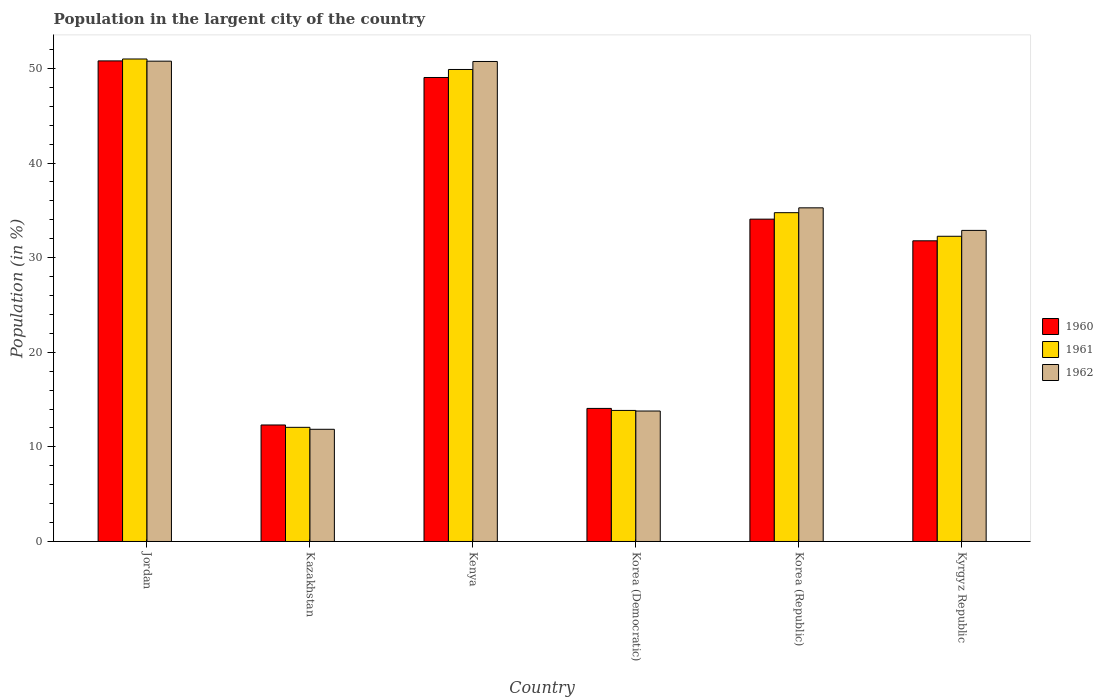How many different coloured bars are there?
Provide a succinct answer. 3. How many groups of bars are there?
Offer a very short reply. 6. Are the number of bars per tick equal to the number of legend labels?
Offer a terse response. Yes. How many bars are there on the 2nd tick from the right?
Offer a terse response. 3. What is the label of the 4th group of bars from the left?
Ensure brevity in your answer.  Korea (Democratic). In how many cases, is the number of bars for a given country not equal to the number of legend labels?
Provide a succinct answer. 0. What is the percentage of population in the largent city in 1961 in Kyrgyz Republic?
Your answer should be very brief. 32.26. Across all countries, what is the maximum percentage of population in the largent city in 1961?
Provide a succinct answer. 50.99. Across all countries, what is the minimum percentage of population in the largent city in 1962?
Keep it short and to the point. 11.86. In which country was the percentage of population in the largent city in 1962 maximum?
Ensure brevity in your answer.  Jordan. In which country was the percentage of population in the largent city in 1961 minimum?
Your answer should be very brief. Kazakhstan. What is the total percentage of population in the largent city in 1962 in the graph?
Your answer should be compact. 195.28. What is the difference between the percentage of population in the largent city in 1960 in Kazakhstan and that in Kenya?
Provide a short and direct response. -36.73. What is the difference between the percentage of population in the largent city in 1960 in Korea (Democratic) and the percentage of population in the largent city in 1961 in Kazakhstan?
Offer a terse response. 2. What is the average percentage of population in the largent city in 1962 per country?
Ensure brevity in your answer.  32.55. What is the difference between the percentage of population in the largent city of/in 1960 and percentage of population in the largent city of/in 1962 in Jordan?
Your answer should be compact. 0.03. In how many countries, is the percentage of population in the largent city in 1962 greater than 16 %?
Offer a terse response. 4. What is the ratio of the percentage of population in the largent city in 1960 in Jordan to that in Kyrgyz Republic?
Make the answer very short. 1.6. Is the percentage of population in the largent city in 1960 in Jordan less than that in Korea (Democratic)?
Provide a short and direct response. No. Is the difference between the percentage of population in the largent city in 1960 in Kenya and Korea (Republic) greater than the difference between the percentage of population in the largent city in 1962 in Kenya and Korea (Republic)?
Your response must be concise. No. What is the difference between the highest and the second highest percentage of population in the largent city in 1962?
Keep it short and to the point. 15.5. What is the difference between the highest and the lowest percentage of population in the largent city in 1961?
Provide a short and direct response. 38.93. Is the sum of the percentage of population in the largent city in 1960 in Korea (Democratic) and Kyrgyz Republic greater than the maximum percentage of population in the largent city in 1962 across all countries?
Your answer should be very brief. No. What does the 2nd bar from the left in Kenya represents?
Offer a very short reply. 1961. Is it the case that in every country, the sum of the percentage of population in the largent city in 1962 and percentage of population in the largent city in 1961 is greater than the percentage of population in the largent city in 1960?
Your answer should be compact. Yes. Does the graph contain grids?
Your answer should be compact. No. Where does the legend appear in the graph?
Offer a terse response. Center right. How many legend labels are there?
Make the answer very short. 3. How are the legend labels stacked?
Keep it short and to the point. Vertical. What is the title of the graph?
Your answer should be very brief. Population in the largent city of the country. What is the Population (in %) of 1960 in Jordan?
Your answer should be very brief. 50.79. What is the Population (in %) in 1961 in Jordan?
Offer a very short reply. 50.99. What is the Population (in %) of 1962 in Jordan?
Give a very brief answer. 50.76. What is the Population (in %) in 1960 in Kazakhstan?
Make the answer very short. 12.31. What is the Population (in %) in 1961 in Kazakhstan?
Provide a succinct answer. 12.06. What is the Population (in %) of 1962 in Kazakhstan?
Your answer should be compact. 11.86. What is the Population (in %) in 1960 in Kenya?
Your answer should be compact. 49.04. What is the Population (in %) in 1961 in Kenya?
Provide a short and direct response. 49.89. What is the Population (in %) of 1962 in Kenya?
Your answer should be very brief. 50.73. What is the Population (in %) in 1960 in Korea (Democratic)?
Give a very brief answer. 14.06. What is the Population (in %) of 1961 in Korea (Democratic)?
Offer a very short reply. 13.85. What is the Population (in %) in 1962 in Korea (Democratic)?
Offer a very short reply. 13.79. What is the Population (in %) of 1960 in Korea (Republic)?
Provide a short and direct response. 34.07. What is the Population (in %) of 1961 in Korea (Republic)?
Ensure brevity in your answer.  34.75. What is the Population (in %) of 1962 in Korea (Republic)?
Give a very brief answer. 35.26. What is the Population (in %) of 1960 in Kyrgyz Republic?
Give a very brief answer. 31.78. What is the Population (in %) of 1961 in Kyrgyz Republic?
Your answer should be compact. 32.26. What is the Population (in %) in 1962 in Kyrgyz Republic?
Your answer should be compact. 32.88. Across all countries, what is the maximum Population (in %) of 1960?
Offer a terse response. 50.79. Across all countries, what is the maximum Population (in %) of 1961?
Ensure brevity in your answer.  50.99. Across all countries, what is the maximum Population (in %) of 1962?
Give a very brief answer. 50.76. Across all countries, what is the minimum Population (in %) of 1960?
Provide a succinct answer. 12.31. Across all countries, what is the minimum Population (in %) in 1961?
Your response must be concise. 12.06. Across all countries, what is the minimum Population (in %) of 1962?
Your answer should be compact. 11.86. What is the total Population (in %) in 1960 in the graph?
Make the answer very short. 192.05. What is the total Population (in %) of 1961 in the graph?
Make the answer very short. 193.8. What is the total Population (in %) of 1962 in the graph?
Make the answer very short. 195.28. What is the difference between the Population (in %) of 1960 in Jordan and that in Kazakhstan?
Provide a succinct answer. 38.48. What is the difference between the Population (in %) of 1961 in Jordan and that in Kazakhstan?
Provide a succinct answer. 38.93. What is the difference between the Population (in %) in 1962 in Jordan and that in Kazakhstan?
Provide a short and direct response. 38.91. What is the difference between the Population (in %) in 1960 in Jordan and that in Kenya?
Offer a terse response. 1.75. What is the difference between the Population (in %) of 1961 in Jordan and that in Kenya?
Your answer should be compact. 1.11. What is the difference between the Population (in %) in 1962 in Jordan and that in Kenya?
Provide a succinct answer. 0.03. What is the difference between the Population (in %) of 1960 in Jordan and that in Korea (Democratic)?
Offer a very short reply. 36.73. What is the difference between the Population (in %) of 1961 in Jordan and that in Korea (Democratic)?
Provide a short and direct response. 37.14. What is the difference between the Population (in %) of 1962 in Jordan and that in Korea (Democratic)?
Give a very brief answer. 36.98. What is the difference between the Population (in %) of 1960 in Jordan and that in Korea (Republic)?
Keep it short and to the point. 16.73. What is the difference between the Population (in %) of 1961 in Jordan and that in Korea (Republic)?
Your answer should be very brief. 16.24. What is the difference between the Population (in %) of 1962 in Jordan and that in Korea (Republic)?
Keep it short and to the point. 15.5. What is the difference between the Population (in %) in 1960 in Jordan and that in Kyrgyz Republic?
Offer a very short reply. 19.01. What is the difference between the Population (in %) of 1961 in Jordan and that in Kyrgyz Republic?
Your answer should be very brief. 18.74. What is the difference between the Population (in %) in 1962 in Jordan and that in Kyrgyz Republic?
Ensure brevity in your answer.  17.89. What is the difference between the Population (in %) of 1960 in Kazakhstan and that in Kenya?
Offer a terse response. -36.73. What is the difference between the Population (in %) of 1961 in Kazakhstan and that in Kenya?
Give a very brief answer. -37.82. What is the difference between the Population (in %) of 1962 in Kazakhstan and that in Kenya?
Keep it short and to the point. -38.88. What is the difference between the Population (in %) in 1960 in Kazakhstan and that in Korea (Democratic)?
Provide a succinct answer. -1.75. What is the difference between the Population (in %) in 1961 in Kazakhstan and that in Korea (Democratic)?
Offer a terse response. -1.79. What is the difference between the Population (in %) in 1962 in Kazakhstan and that in Korea (Democratic)?
Provide a succinct answer. -1.93. What is the difference between the Population (in %) in 1960 in Kazakhstan and that in Korea (Republic)?
Offer a very short reply. -21.75. What is the difference between the Population (in %) of 1961 in Kazakhstan and that in Korea (Republic)?
Make the answer very short. -22.69. What is the difference between the Population (in %) of 1962 in Kazakhstan and that in Korea (Republic)?
Your response must be concise. -23.41. What is the difference between the Population (in %) of 1960 in Kazakhstan and that in Kyrgyz Republic?
Provide a short and direct response. -19.46. What is the difference between the Population (in %) in 1961 in Kazakhstan and that in Kyrgyz Republic?
Your answer should be compact. -20.19. What is the difference between the Population (in %) of 1962 in Kazakhstan and that in Kyrgyz Republic?
Offer a terse response. -21.02. What is the difference between the Population (in %) in 1960 in Kenya and that in Korea (Democratic)?
Your response must be concise. 34.97. What is the difference between the Population (in %) in 1961 in Kenya and that in Korea (Democratic)?
Ensure brevity in your answer.  36.04. What is the difference between the Population (in %) of 1962 in Kenya and that in Korea (Democratic)?
Offer a terse response. 36.94. What is the difference between the Population (in %) of 1960 in Kenya and that in Korea (Republic)?
Your answer should be compact. 14.97. What is the difference between the Population (in %) in 1961 in Kenya and that in Korea (Republic)?
Keep it short and to the point. 15.14. What is the difference between the Population (in %) in 1962 in Kenya and that in Korea (Republic)?
Make the answer very short. 15.47. What is the difference between the Population (in %) in 1960 in Kenya and that in Kyrgyz Republic?
Offer a very short reply. 17.26. What is the difference between the Population (in %) in 1961 in Kenya and that in Kyrgyz Republic?
Your answer should be very brief. 17.63. What is the difference between the Population (in %) of 1962 in Kenya and that in Kyrgyz Republic?
Provide a succinct answer. 17.85. What is the difference between the Population (in %) of 1960 in Korea (Democratic) and that in Korea (Republic)?
Offer a terse response. -20. What is the difference between the Population (in %) in 1961 in Korea (Democratic) and that in Korea (Republic)?
Provide a succinct answer. -20.9. What is the difference between the Population (in %) of 1962 in Korea (Democratic) and that in Korea (Republic)?
Offer a very short reply. -21.47. What is the difference between the Population (in %) in 1960 in Korea (Democratic) and that in Kyrgyz Republic?
Your answer should be very brief. -17.71. What is the difference between the Population (in %) of 1961 in Korea (Democratic) and that in Kyrgyz Republic?
Offer a very short reply. -18.41. What is the difference between the Population (in %) of 1962 in Korea (Democratic) and that in Kyrgyz Republic?
Make the answer very short. -19.09. What is the difference between the Population (in %) in 1960 in Korea (Republic) and that in Kyrgyz Republic?
Make the answer very short. 2.29. What is the difference between the Population (in %) in 1961 in Korea (Republic) and that in Kyrgyz Republic?
Make the answer very short. 2.49. What is the difference between the Population (in %) of 1962 in Korea (Republic) and that in Kyrgyz Republic?
Make the answer very short. 2.38. What is the difference between the Population (in %) of 1960 in Jordan and the Population (in %) of 1961 in Kazakhstan?
Keep it short and to the point. 38.73. What is the difference between the Population (in %) in 1960 in Jordan and the Population (in %) in 1962 in Kazakhstan?
Offer a terse response. 38.94. What is the difference between the Population (in %) of 1961 in Jordan and the Population (in %) of 1962 in Kazakhstan?
Your answer should be very brief. 39.14. What is the difference between the Population (in %) in 1960 in Jordan and the Population (in %) in 1961 in Kenya?
Provide a short and direct response. 0.91. What is the difference between the Population (in %) of 1960 in Jordan and the Population (in %) of 1962 in Kenya?
Keep it short and to the point. 0.06. What is the difference between the Population (in %) of 1961 in Jordan and the Population (in %) of 1962 in Kenya?
Offer a terse response. 0.26. What is the difference between the Population (in %) of 1960 in Jordan and the Population (in %) of 1961 in Korea (Democratic)?
Offer a very short reply. 36.94. What is the difference between the Population (in %) of 1960 in Jordan and the Population (in %) of 1962 in Korea (Democratic)?
Provide a short and direct response. 37. What is the difference between the Population (in %) of 1961 in Jordan and the Population (in %) of 1962 in Korea (Democratic)?
Your answer should be compact. 37.21. What is the difference between the Population (in %) in 1960 in Jordan and the Population (in %) in 1961 in Korea (Republic)?
Provide a short and direct response. 16.04. What is the difference between the Population (in %) of 1960 in Jordan and the Population (in %) of 1962 in Korea (Republic)?
Offer a very short reply. 15.53. What is the difference between the Population (in %) of 1961 in Jordan and the Population (in %) of 1962 in Korea (Republic)?
Keep it short and to the point. 15.73. What is the difference between the Population (in %) in 1960 in Jordan and the Population (in %) in 1961 in Kyrgyz Republic?
Provide a short and direct response. 18.54. What is the difference between the Population (in %) of 1960 in Jordan and the Population (in %) of 1962 in Kyrgyz Republic?
Your response must be concise. 17.91. What is the difference between the Population (in %) of 1961 in Jordan and the Population (in %) of 1962 in Kyrgyz Republic?
Offer a terse response. 18.12. What is the difference between the Population (in %) of 1960 in Kazakhstan and the Population (in %) of 1961 in Kenya?
Offer a very short reply. -37.57. What is the difference between the Population (in %) in 1960 in Kazakhstan and the Population (in %) in 1962 in Kenya?
Your answer should be compact. -38.42. What is the difference between the Population (in %) of 1961 in Kazakhstan and the Population (in %) of 1962 in Kenya?
Offer a terse response. -38.67. What is the difference between the Population (in %) in 1960 in Kazakhstan and the Population (in %) in 1961 in Korea (Democratic)?
Ensure brevity in your answer.  -1.54. What is the difference between the Population (in %) in 1960 in Kazakhstan and the Population (in %) in 1962 in Korea (Democratic)?
Your answer should be very brief. -1.47. What is the difference between the Population (in %) in 1961 in Kazakhstan and the Population (in %) in 1962 in Korea (Democratic)?
Keep it short and to the point. -1.72. What is the difference between the Population (in %) in 1960 in Kazakhstan and the Population (in %) in 1961 in Korea (Republic)?
Make the answer very short. -22.44. What is the difference between the Population (in %) in 1960 in Kazakhstan and the Population (in %) in 1962 in Korea (Republic)?
Your answer should be very brief. -22.95. What is the difference between the Population (in %) of 1961 in Kazakhstan and the Population (in %) of 1962 in Korea (Republic)?
Ensure brevity in your answer.  -23.2. What is the difference between the Population (in %) in 1960 in Kazakhstan and the Population (in %) in 1961 in Kyrgyz Republic?
Make the answer very short. -19.94. What is the difference between the Population (in %) of 1960 in Kazakhstan and the Population (in %) of 1962 in Kyrgyz Republic?
Provide a short and direct response. -20.56. What is the difference between the Population (in %) in 1961 in Kazakhstan and the Population (in %) in 1962 in Kyrgyz Republic?
Provide a short and direct response. -20.81. What is the difference between the Population (in %) in 1960 in Kenya and the Population (in %) in 1961 in Korea (Democratic)?
Ensure brevity in your answer.  35.19. What is the difference between the Population (in %) of 1960 in Kenya and the Population (in %) of 1962 in Korea (Democratic)?
Your response must be concise. 35.25. What is the difference between the Population (in %) of 1961 in Kenya and the Population (in %) of 1962 in Korea (Democratic)?
Your answer should be compact. 36.1. What is the difference between the Population (in %) of 1960 in Kenya and the Population (in %) of 1961 in Korea (Republic)?
Your answer should be very brief. 14.29. What is the difference between the Population (in %) of 1960 in Kenya and the Population (in %) of 1962 in Korea (Republic)?
Your response must be concise. 13.78. What is the difference between the Population (in %) in 1961 in Kenya and the Population (in %) in 1962 in Korea (Republic)?
Provide a short and direct response. 14.62. What is the difference between the Population (in %) in 1960 in Kenya and the Population (in %) in 1961 in Kyrgyz Republic?
Provide a succinct answer. 16.78. What is the difference between the Population (in %) of 1960 in Kenya and the Population (in %) of 1962 in Kyrgyz Republic?
Provide a short and direct response. 16.16. What is the difference between the Population (in %) in 1961 in Kenya and the Population (in %) in 1962 in Kyrgyz Republic?
Ensure brevity in your answer.  17.01. What is the difference between the Population (in %) of 1960 in Korea (Democratic) and the Population (in %) of 1961 in Korea (Republic)?
Ensure brevity in your answer.  -20.69. What is the difference between the Population (in %) in 1960 in Korea (Democratic) and the Population (in %) in 1962 in Korea (Republic)?
Your answer should be compact. -21.2. What is the difference between the Population (in %) in 1961 in Korea (Democratic) and the Population (in %) in 1962 in Korea (Republic)?
Offer a terse response. -21.41. What is the difference between the Population (in %) of 1960 in Korea (Democratic) and the Population (in %) of 1961 in Kyrgyz Republic?
Provide a succinct answer. -18.19. What is the difference between the Population (in %) in 1960 in Korea (Democratic) and the Population (in %) in 1962 in Kyrgyz Republic?
Offer a terse response. -18.81. What is the difference between the Population (in %) of 1961 in Korea (Democratic) and the Population (in %) of 1962 in Kyrgyz Republic?
Provide a succinct answer. -19.03. What is the difference between the Population (in %) of 1960 in Korea (Republic) and the Population (in %) of 1961 in Kyrgyz Republic?
Your answer should be very brief. 1.81. What is the difference between the Population (in %) in 1960 in Korea (Republic) and the Population (in %) in 1962 in Kyrgyz Republic?
Your answer should be very brief. 1.19. What is the difference between the Population (in %) in 1961 in Korea (Republic) and the Population (in %) in 1962 in Kyrgyz Republic?
Your answer should be compact. 1.87. What is the average Population (in %) of 1960 per country?
Provide a succinct answer. 32.01. What is the average Population (in %) of 1961 per country?
Make the answer very short. 32.3. What is the average Population (in %) of 1962 per country?
Provide a short and direct response. 32.55. What is the difference between the Population (in %) in 1960 and Population (in %) in 1961 in Jordan?
Provide a short and direct response. -0.2. What is the difference between the Population (in %) in 1960 and Population (in %) in 1962 in Jordan?
Your answer should be very brief. 0.03. What is the difference between the Population (in %) of 1961 and Population (in %) of 1962 in Jordan?
Your answer should be very brief. 0.23. What is the difference between the Population (in %) of 1960 and Population (in %) of 1961 in Kazakhstan?
Give a very brief answer. 0.25. What is the difference between the Population (in %) of 1960 and Population (in %) of 1962 in Kazakhstan?
Provide a succinct answer. 0.46. What is the difference between the Population (in %) of 1961 and Population (in %) of 1962 in Kazakhstan?
Your response must be concise. 0.21. What is the difference between the Population (in %) of 1960 and Population (in %) of 1961 in Kenya?
Ensure brevity in your answer.  -0.85. What is the difference between the Population (in %) in 1960 and Population (in %) in 1962 in Kenya?
Your answer should be very brief. -1.69. What is the difference between the Population (in %) of 1961 and Population (in %) of 1962 in Kenya?
Your response must be concise. -0.85. What is the difference between the Population (in %) of 1960 and Population (in %) of 1961 in Korea (Democratic)?
Make the answer very short. 0.21. What is the difference between the Population (in %) of 1960 and Population (in %) of 1962 in Korea (Democratic)?
Provide a short and direct response. 0.28. What is the difference between the Population (in %) in 1961 and Population (in %) in 1962 in Korea (Democratic)?
Offer a very short reply. 0.06. What is the difference between the Population (in %) of 1960 and Population (in %) of 1961 in Korea (Republic)?
Offer a terse response. -0.68. What is the difference between the Population (in %) in 1960 and Population (in %) in 1962 in Korea (Republic)?
Offer a terse response. -1.19. What is the difference between the Population (in %) in 1961 and Population (in %) in 1962 in Korea (Republic)?
Offer a very short reply. -0.51. What is the difference between the Population (in %) of 1960 and Population (in %) of 1961 in Kyrgyz Republic?
Provide a short and direct response. -0.48. What is the difference between the Population (in %) in 1960 and Population (in %) in 1962 in Kyrgyz Republic?
Offer a terse response. -1.1. What is the difference between the Population (in %) of 1961 and Population (in %) of 1962 in Kyrgyz Republic?
Offer a terse response. -0.62. What is the ratio of the Population (in %) of 1960 in Jordan to that in Kazakhstan?
Offer a terse response. 4.13. What is the ratio of the Population (in %) in 1961 in Jordan to that in Kazakhstan?
Offer a very short reply. 4.23. What is the ratio of the Population (in %) of 1962 in Jordan to that in Kazakhstan?
Ensure brevity in your answer.  4.28. What is the ratio of the Population (in %) in 1960 in Jordan to that in Kenya?
Offer a very short reply. 1.04. What is the ratio of the Population (in %) in 1961 in Jordan to that in Kenya?
Your answer should be very brief. 1.02. What is the ratio of the Population (in %) in 1960 in Jordan to that in Korea (Democratic)?
Offer a terse response. 3.61. What is the ratio of the Population (in %) in 1961 in Jordan to that in Korea (Democratic)?
Provide a short and direct response. 3.68. What is the ratio of the Population (in %) in 1962 in Jordan to that in Korea (Democratic)?
Give a very brief answer. 3.68. What is the ratio of the Population (in %) in 1960 in Jordan to that in Korea (Republic)?
Offer a very short reply. 1.49. What is the ratio of the Population (in %) in 1961 in Jordan to that in Korea (Republic)?
Your answer should be very brief. 1.47. What is the ratio of the Population (in %) of 1962 in Jordan to that in Korea (Republic)?
Offer a terse response. 1.44. What is the ratio of the Population (in %) of 1960 in Jordan to that in Kyrgyz Republic?
Give a very brief answer. 1.6. What is the ratio of the Population (in %) of 1961 in Jordan to that in Kyrgyz Republic?
Your answer should be very brief. 1.58. What is the ratio of the Population (in %) in 1962 in Jordan to that in Kyrgyz Republic?
Provide a short and direct response. 1.54. What is the ratio of the Population (in %) of 1960 in Kazakhstan to that in Kenya?
Offer a very short reply. 0.25. What is the ratio of the Population (in %) in 1961 in Kazakhstan to that in Kenya?
Provide a succinct answer. 0.24. What is the ratio of the Population (in %) in 1962 in Kazakhstan to that in Kenya?
Offer a terse response. 0.23. What is the ratio of the Population (in %) of 1960 in Kazakhstan to that in Korea (Democratic)?
Ensure brevity in your answer.  0.88. What is the ratio of the Population (in %) of 1961 in Kazakhstan to that in Korea (Democratic)?
Your answer should be very brief. 0.87. What is the ratio of the Population (in %) in 1962 in Kazakhstan to that in Korea (Democratic)?
Ensure brevity in your answer.  0.86. What is the ratio of the Population (in %) in 1960 in Kazakhstan to that in Korea (Republic)?
Your response must be concise. 0.36. What is the ratio of the Population (in %) in 1961 in Kazakhstan to that in Korea (Republic)?
Make the answer very short. 0.35. What is the ratio of the Population (in %) in 1962 in Kazakhstan to that in Korea (Republic)?
Make the answer very short. 0.34. What is the ratio of the Population (in %) in 1960 in Kazakhstan to that in Kyrgyz Republic?
Offer a very short reply. 0.39. What is the ratio of the Population (in %) of 1961 in Kazakhstan to that in Kyrgyz Republic?
Provide a succinct answer. 0.37. What is the ratio of the Population (in %) of 1962 in Kazakhstan to that in Kyrgyz Republic?
Provide a short and direct response. 0.36. What is the ratio of the Population (in %) of 1960 in Kenya to that in Korea (Democratic)?
Provide a succinct answer. 3.49. What is the ratio of the Population (in %) of 1961 in Kenya to that in Korea (Democratic)?
Your response must be concise. 3.6. What is the ratio of the Population (in %) of 1962 in Kenya to that in Korea (Democratic)?
Make the answer very short. 3.68. What is the ratio of the Population (in %) of 1960 in Kenya to that in Korea (Republic)?
Keep it short and to the point. 1.44. What is the ratio of the Population (in %) in 1961 in Kenya to that in Korea (Republic)?
Ensure brevity in your answer.  1.44. What is the ratio of the Population (in %) of 1962 in Kenya to that in Korea (Republic)?
Offer a very short reply. 1.44. What is the ratio of the Population (in %) of 1960 in Kenya to that in Kyrgyz Republic?
Offer a very short reply. 1.54. What is the ratio of the Population (in %) of 1961 in Kenya to that in Kyrgyz Republic?
Your answer should be compact. 1.55. What is the ratio of the Population (in %) in 1962 in Kenya to that in Kyrgyz Republic?
Keep it short and to the point. 1.54. What is the ratio of the Population (in %) in 1960 in Korea (Democratic) to that in Korea (Republic)?
Offer a terse response. 0.41. What is the ratio of the Population (in %) of 1961 in Korea (Democratic) to that in Korea (Republic)?
Provide a succinct answer. 0.4. What is the ratio of the Population (in %) of 1962 in Korea (Democratic) to that in Korea (Republic)?
Your answer should be very brief. 0.39. What is the ratio of the Population (in %) in 1960 in Korea (Democratic) to that in Kyrgyz Republic?
Keep it short and to the point. 0.44. What is the ratio of the Population (in %) in 1961 in Korea (Democratic) to that in Kyrgyz Republic?
Offer a very short reply. 0.43. What is the ratio of the Population (in %) of 1962 in Korea (Democratic) to that in Kyrgyz Republic?
Provide a short and direct response. 0.42. What is the ratio of the Population (in %) of 1960 in Korea (Republic) to that in Kyrgyz Republic?
Your answer should be compact. 1.07. What is the ratio of the Population (in %) in 1961 in Korea (Republic) to that in Kyrgyz Republic?
Provide a short and direct response. 1.08. What is the ratio of the Population (in %) in 1962 in Korea (Republic) to that in Kyrgyz Republic?
Provide a short and direct response. 1.07. What is the difference between the highest and the second highest Population (in %) in 1960?
Offer a very short reply. 1.75. What is the difference between the highest and the second highest Population (in %) of 1961?
Ensure brevity in your answer.  1.11. What is the difference between the highest and the second highest Population (in %) of 1962?
Make the answer very short. 0.03. What is the difference between the highest and the lowest Population (in %) in 1960?
Offer a terse response. 38.48. What is the difference between the highest and the lowest Population (in %) of 1961?
Make the answer very short. 38.93. What is the difference between the highest and the lowest Population (in %) in 1962?
Give a very brief answer. 38.91. 